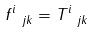<formula> <loc_0><loc_0><loc_500><loc_500>f ^ { i } _ { \ j k } = T ^ { i } _ { \ j k } \</formula> 